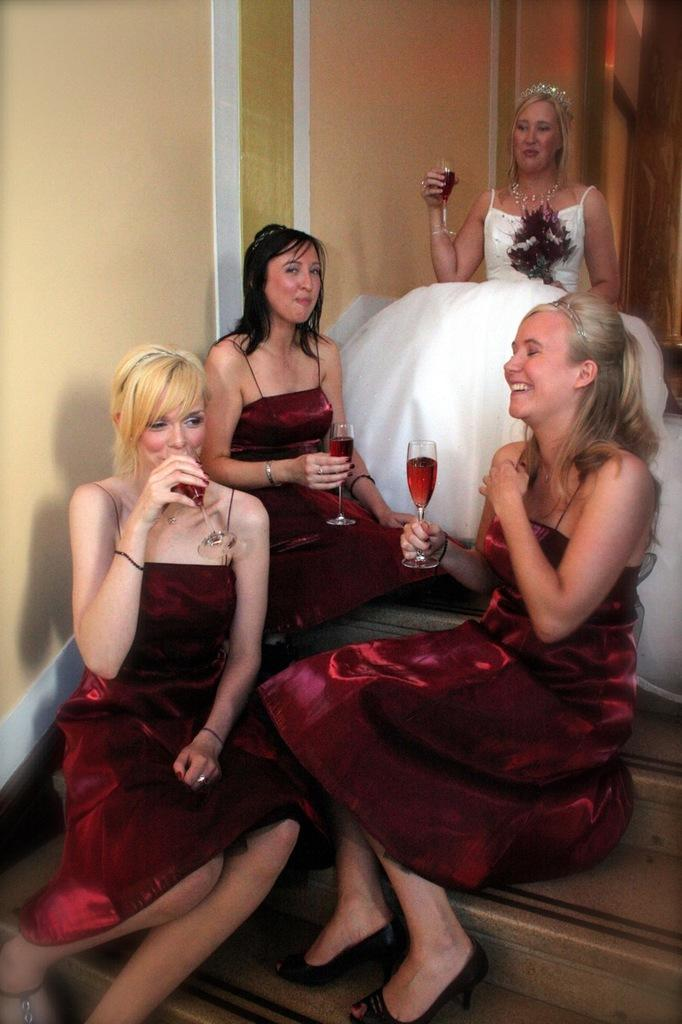What type of location is depicted in the image? The image shows an inside view of a building. What are the people in the image doing? The people are sitting on the stairs. What are the people holding in their hands? The people are holding a glass to drink. What type of muscle can be seen flexing in the image? There is no muscle visible in the image; it shows people sitting on stairs and holding glasses. What is the primary emotion expressed by the people in the image? The image does not convey any specific emotions, as the people are simply sitting and holding glasses. 